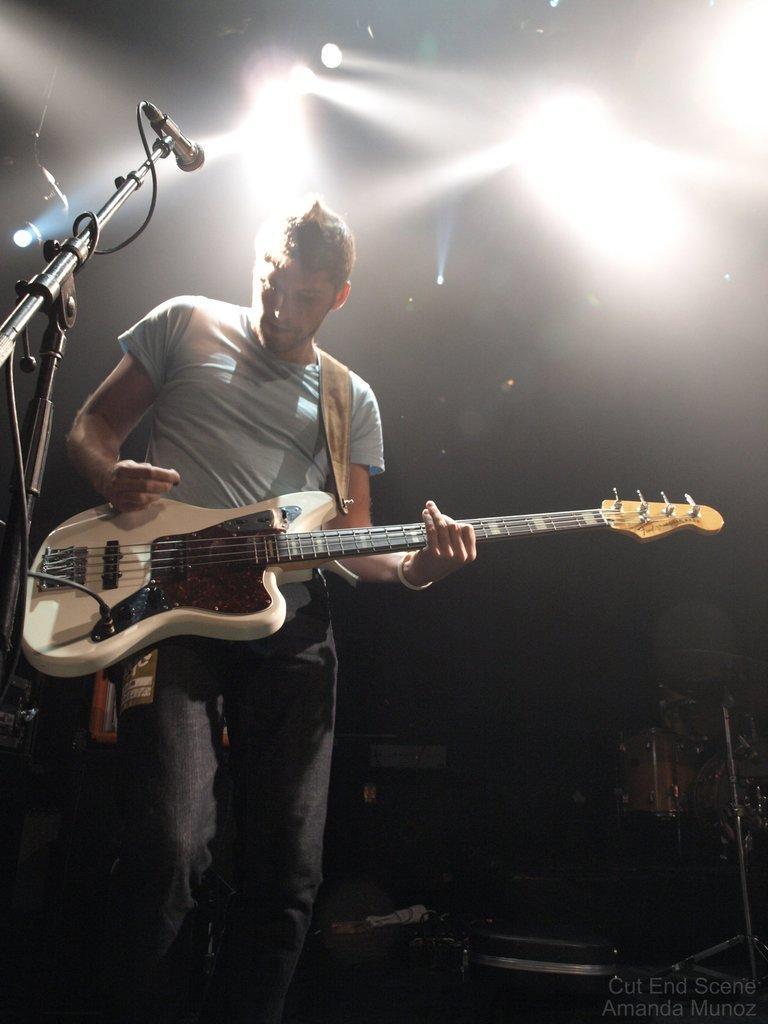How would you summarize this image in a sentence or two? On the image we can see there is a man who is holding a guitar in his hand. 